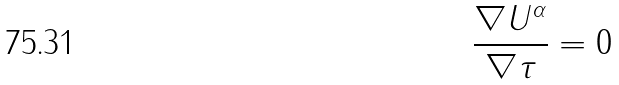Convert formula to latex. <formula><loc_0><loc_0><loc_500><loc_500>\frac { \nabla U ^ { \alpha } } { \nabla \tau } = 0</formula> 